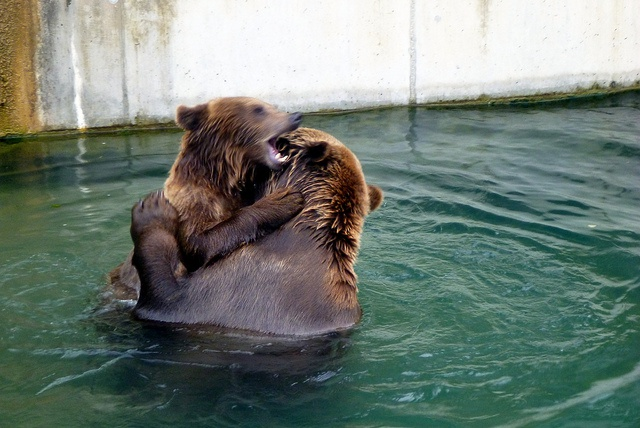Describe the objects in this image and their specific colors. I can see bear in gray, black, and maroon tones and bear in gray, black, and maroon tones in this image. 